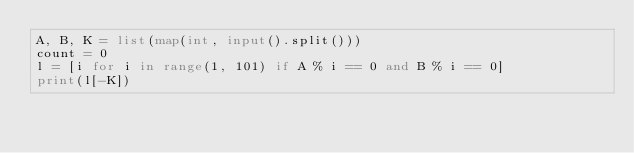Convert code to text. <code><loc_0><loc_0><loc_500><loc_500><_Python_>A, B, K = list(map(int, input().split()))
count = 0
l = [i for i in range(1, 101) if A % i == 0 and B % i == 0]
print(l[-K])</code> 